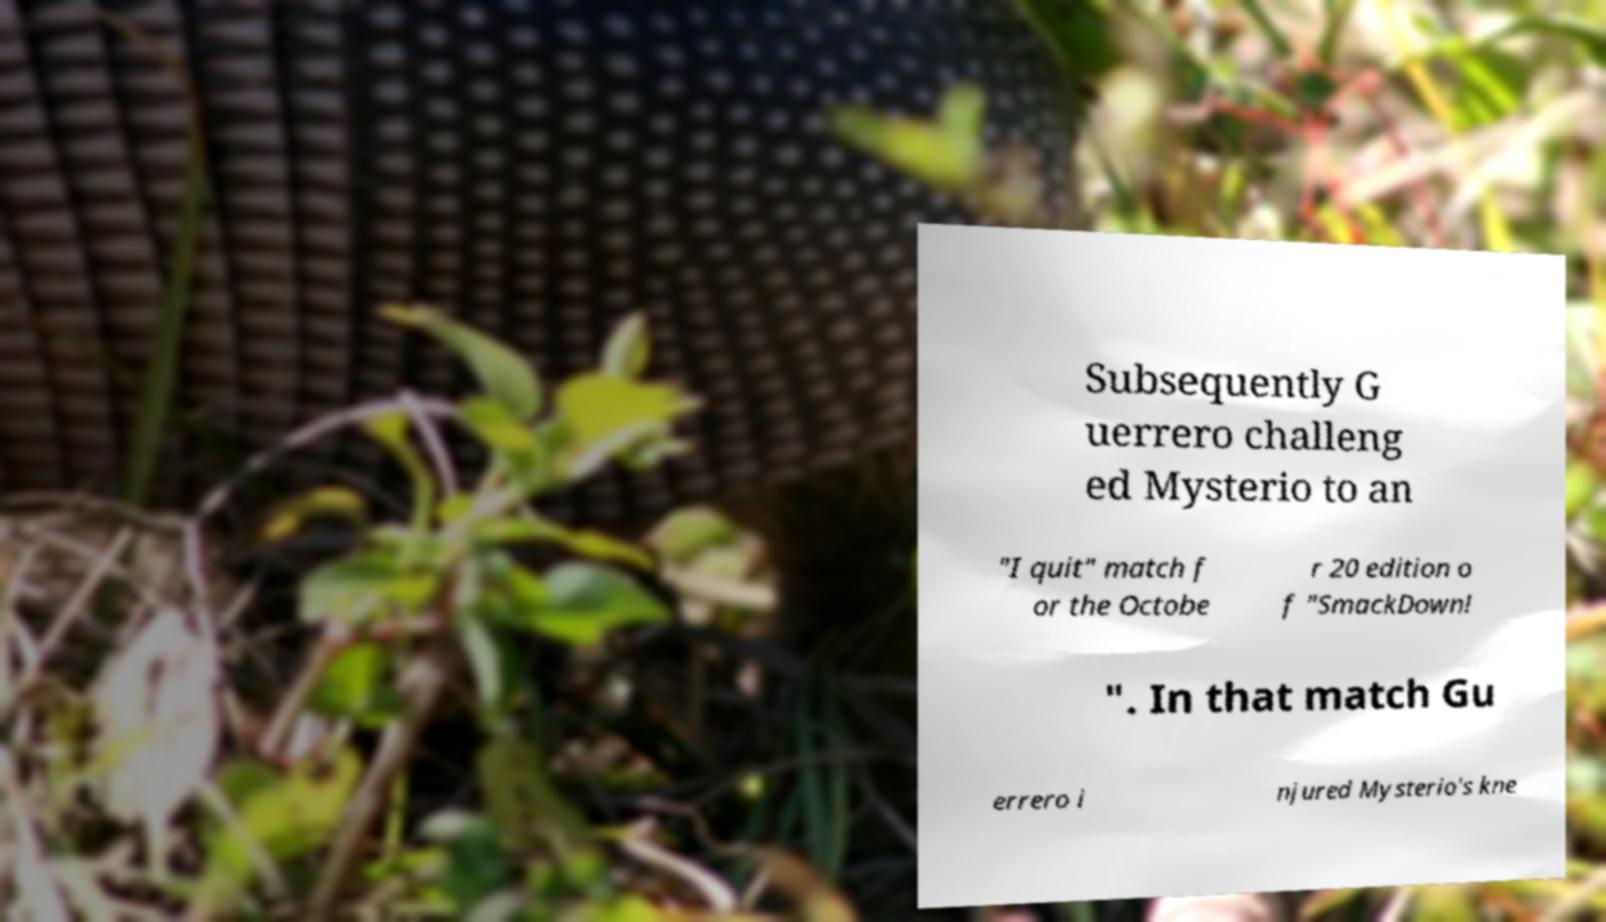Could you assist in decoding the text presented in this image and type it out clearly? Subsequently G uerrero challeng ed Mysterio to an "I quit" match f or the Octobe r 20 edition o f "SmackDown! ". In that match Gu errero i njured Mysterio's kne 